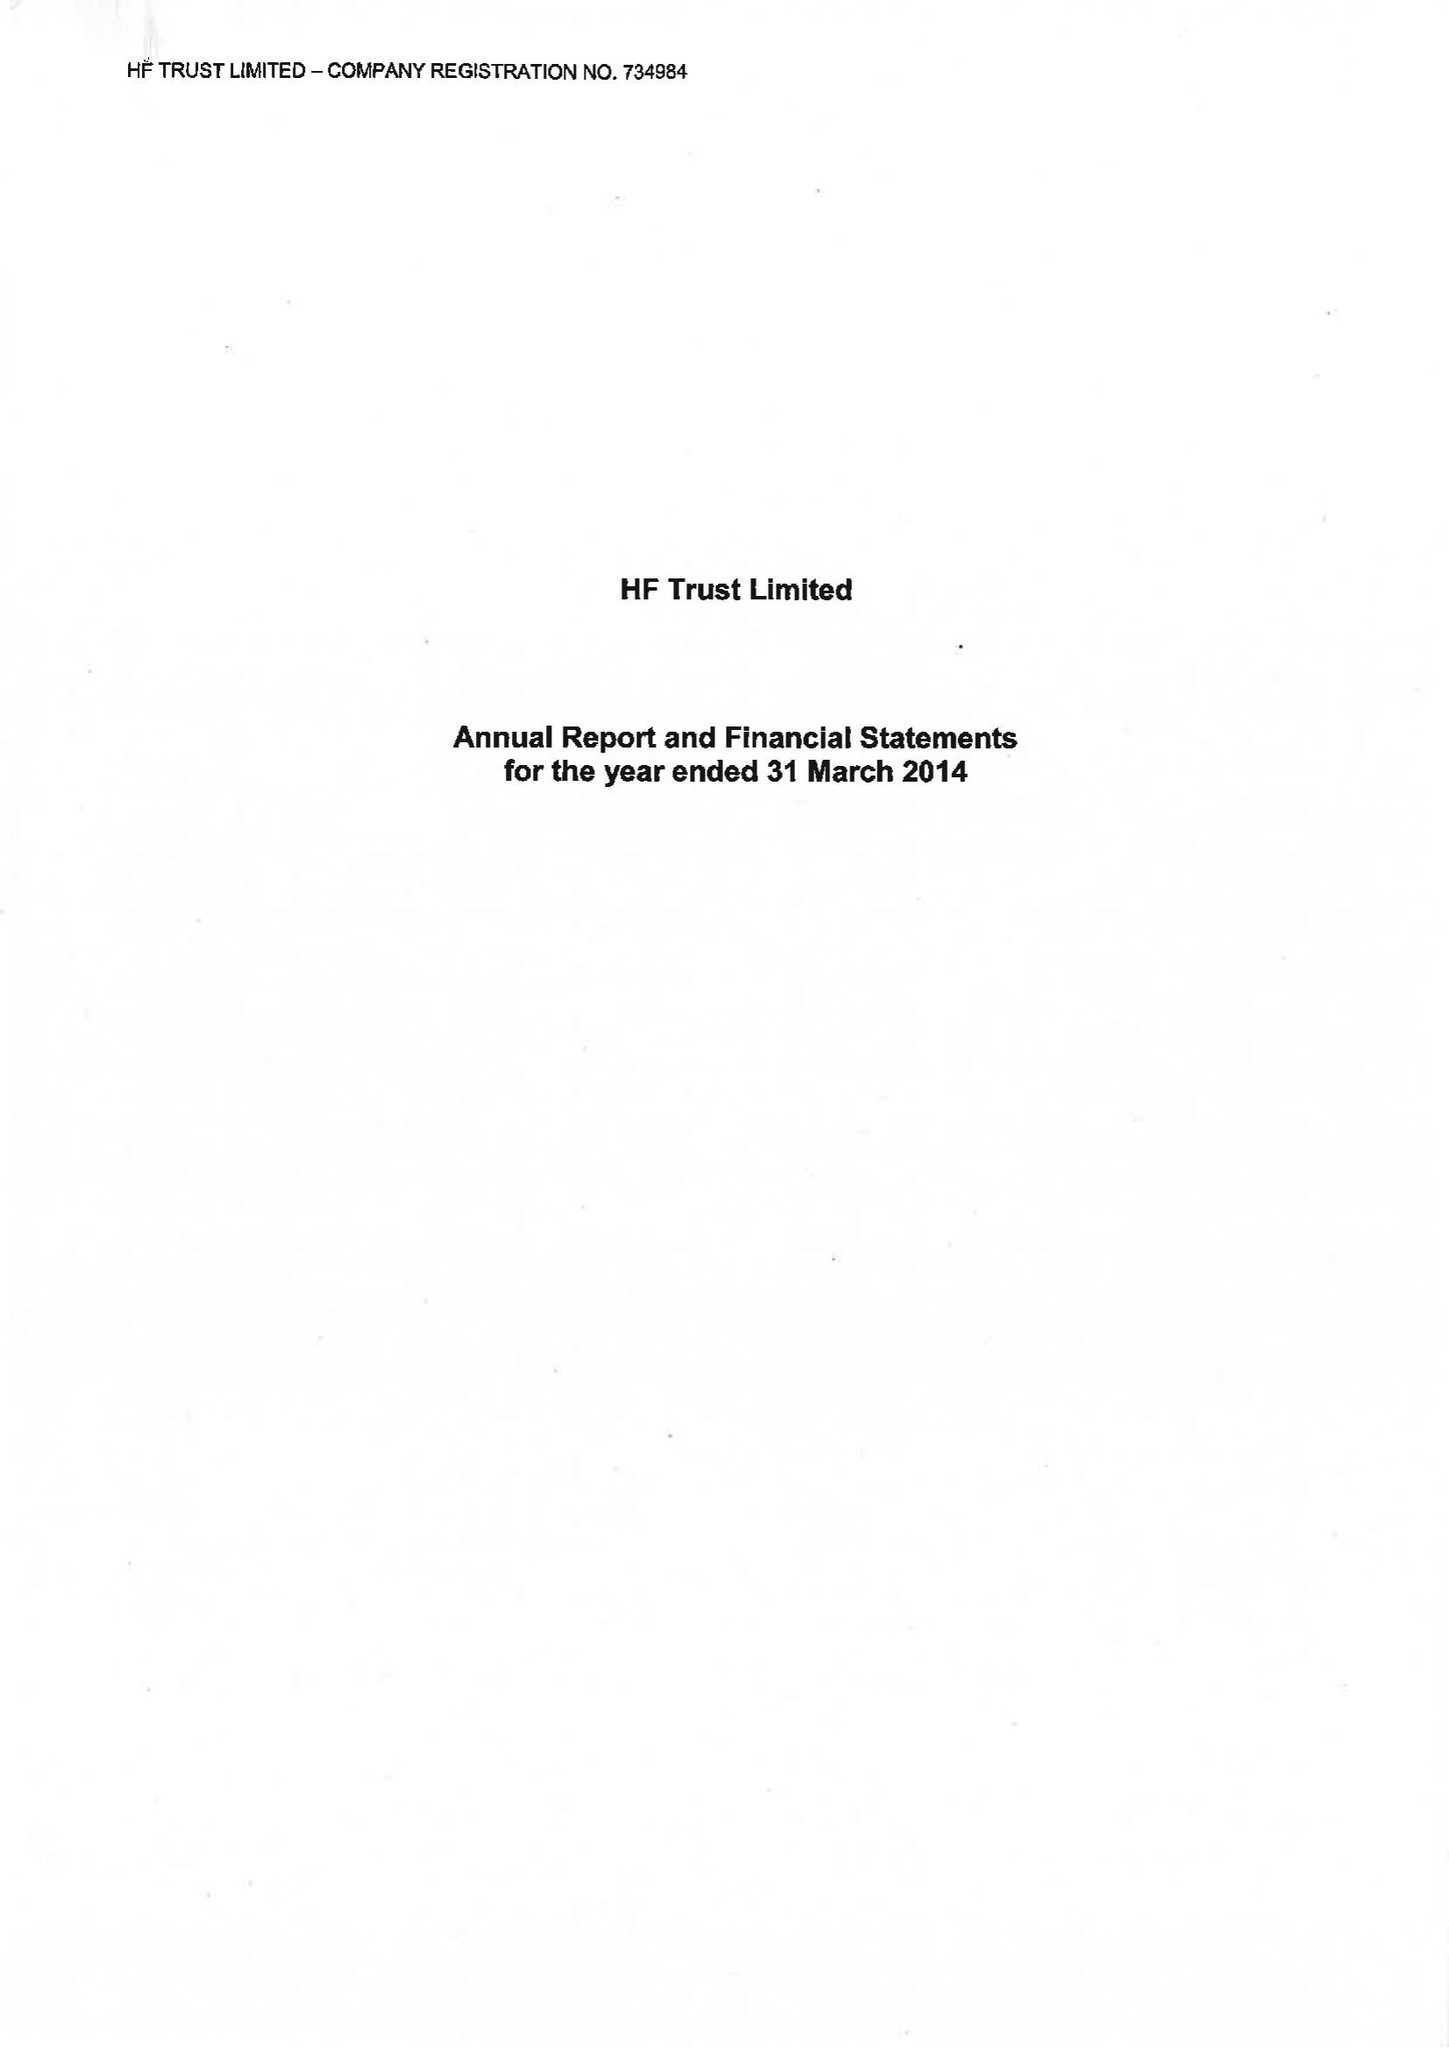What is the value for the address__street_line?
Answer the question using a single word or phrase. None 